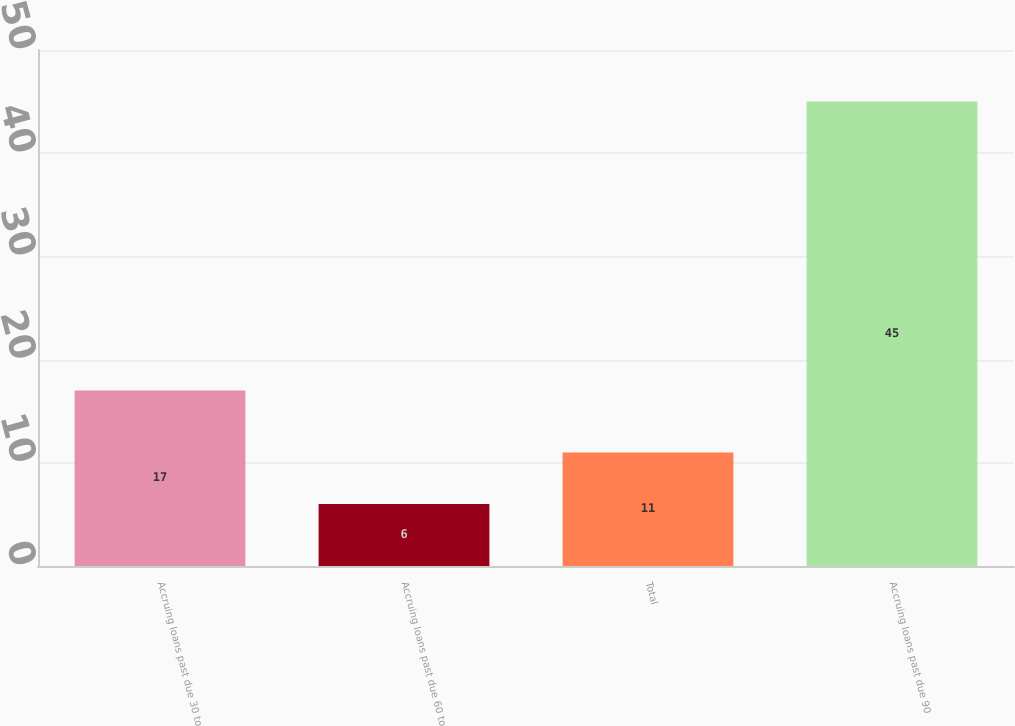Convert chart to OTSL. <chart><loc_0><loc_0><loc_500><loc_500><bar_chart><fcel>Accruing loans past due 30 to<fcel>Accruing loans past due 60 to<fcel>Total<fcel>Accruing loans past due 90<nl><fcel>17<fcel>6<fcel>11<fcel>45<nl></chart> 